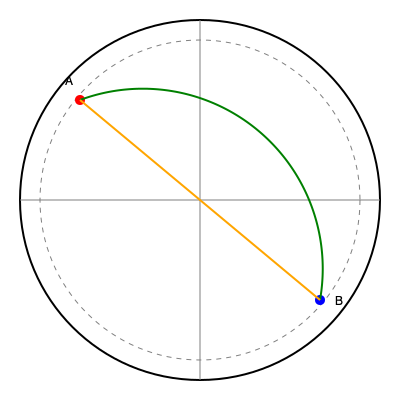In a flight simulation, you need to determine the shortest path between two airports (A and B) on a globe. Given that the straight line (chord) between A and B is 6000 km and the radius of the Earth is 6371 km, what is the length of the great circle arc connecting A and B? Round your answer to the nearest kilometer. To find the length of the great circle arc (the shortest path on the surface of a sphere), we can follow these steps:

1) First, we need to find the central angle $\theta$ between the two points. We can use the chord length formula:

   $c = 2R \sin(\frac{\theta}{2})$

   Where $c$ is the chord length, $R$ is the radius, and $\theta$ is the central angle in radians.

2) We know $c = 6000$ km and $R = 6371$ km. Let's substitute these values:

   $6000 = 2(6371) \sin(\frac{\theta}{2})$

3) Solve for $\theta$:

   $\frac{6000}{2(6371)} = \sin(\frac{\theta}{2})$
   $\frac{\theta}{2} = \arcsin(\frac{3000}{6371})$
   $\theta = 2 \arcsin(\frac{3000}{6371})$

4) Now that we have $\theta$, we can calculate the arc length $s$ using the formula:

   $s = R\theta$

5) Substituting the values:

   $s = 6371 \cdot 2 \arcsin(\frac{3000}{6371})$

6) Calculate this value:

   $s \approx 6371 \cdot 0.9553 \approx 6086.3$ km

7) Rounding to the nearest kilometer:

   $s \approx 6086$ km

This arc length represents the shortest flight path between the two points on the globe's surface.
Answer: 6086 km 